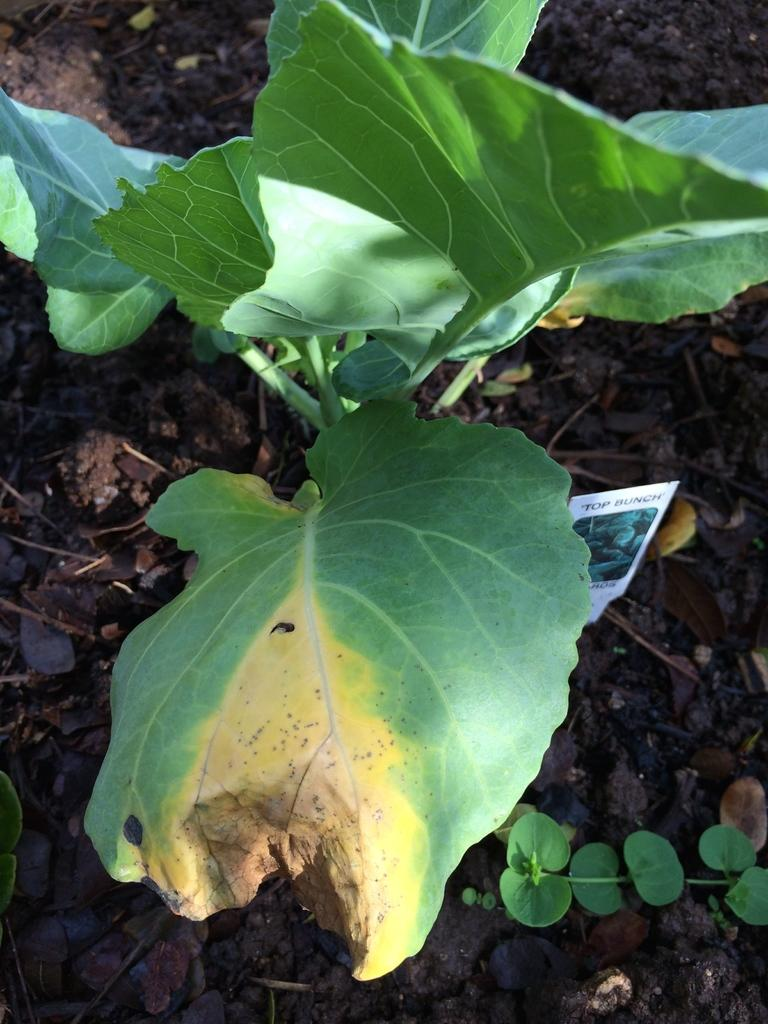What type of vegetation can be seen in the image? There are green color leaves in the image. What other elements are present in the image besides the leaves? There are stones and mud in the image. What is the color of the object in the image? There is a white color object in the image. What is written on the white object? Something is written on the white object. What type of cable can be seen connecting the button to the science experiment in the image? There is no cable, button, or science experiment present in the image. 